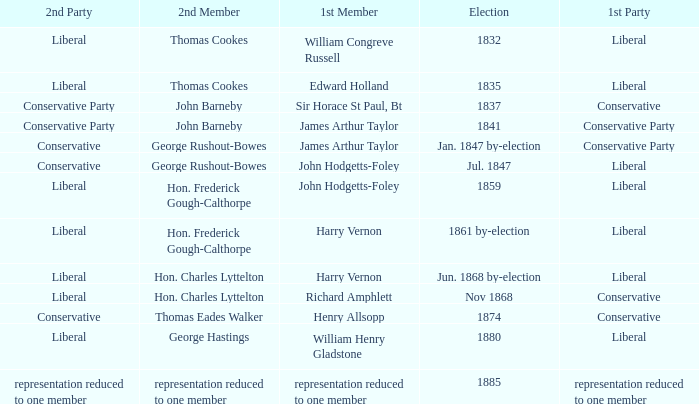What was the 1st Party when the 1st Member was William Congreve Russell? Liberal. 